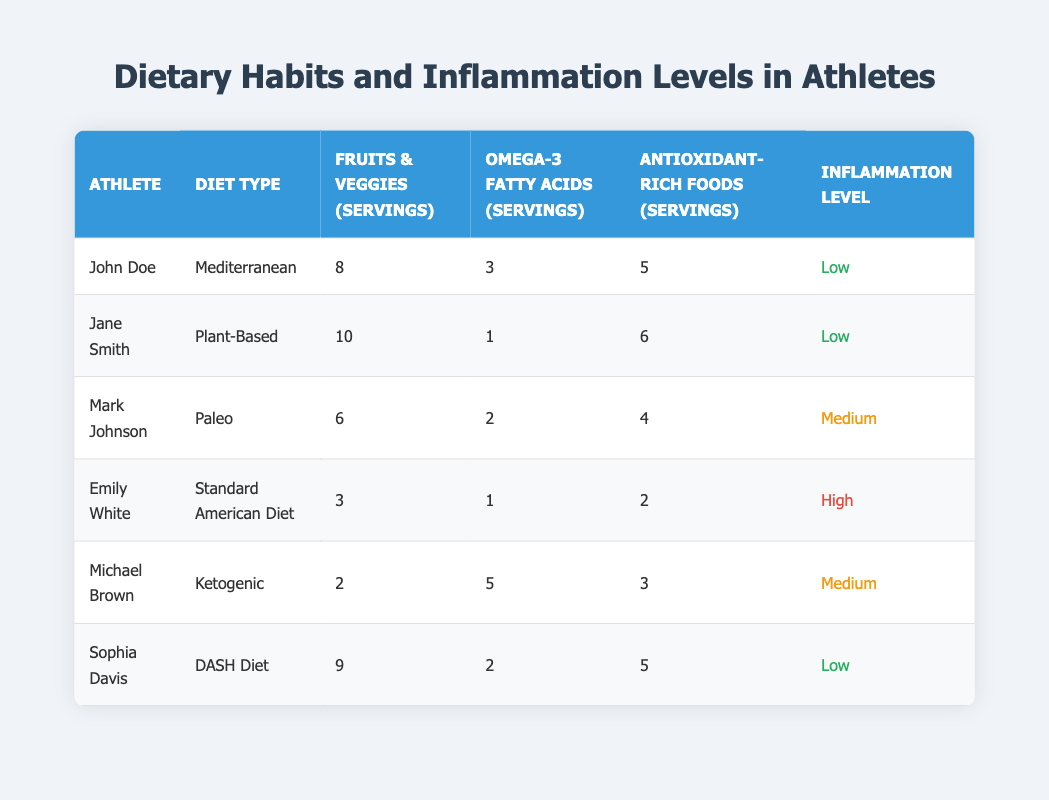What dietary type does Jane Smith follow? Jane Smith's dietary type is listed in the "Diet Type" column, where it specifically states "Plant-Based."
Answer: Plant-Based How many servings of Omega-3 fatty acids does Mark Johnson consume? Mark Johnson's Omega-3 fatty acids serving is in the corresponding row under the "Omega-3 Fatty Acids (Servings)" column, which shows "2."
Answer: 2 Which athlete has the highest consumption of fruits and vegetables? By comparing the values under the "Fruits & Veggies (Servings)" column, Jane Smith has the highest with "10" servings.
Answer: Jane Smith What is the average number of antioxidant-rich food servings across all athletes? To find the average, sum the servings of antioxidant-rich foods: (5 + 6 + 4 + 2 + 3 + 5) = 25. There are 6 athletes, so the average is 25/6, which is approximately 4.17.
Answer: 4.17 Is Emily White's inflammation level low? Checking the "Inflammation Level" column for Emily White yields "High." Therefore, the statement is false.
Answer: No Which dietary type correlates with the lowest levels of inflammation based on the data? Analyzing the "Inflammation Level," the Mediterranean, Plant-Based, and DASH Diet types all show "Low" inflammation, while others vary. Thus, all three can be associated with low inflammation.
Answer: Mediterranean, Plant-Based, DASH Diet What is the difference in servings of fruits and vegetables between the athlete with the highest and lowest inflammation levels? The athlete with the highest inflammation level, Emily White, has 3 servings of fruits and vegetables, while Jane Smith, with the lowest, has 10. The difference is calculated as 10 - 3 = 7.
Answer: 7 Which athlete consumes the highest number of Omega-3 fatty acids and what is their inflammation level? Michael Brown consumes the highest Omega-3 servings with "5," and looking at the "Inflammation Level" for Michael Brown indicates it is "Medium."
Answer: Michael Brown, Medium Is there an athlete who consumes less than 3 servings of fruits and vegetables? Checking the "Fruits & Veggies (Servings)" column confirms that both Michael Brown and Emily White consume 2 and 3 servings, respectively. Therefore, the statement is true.
Answer: Yes 